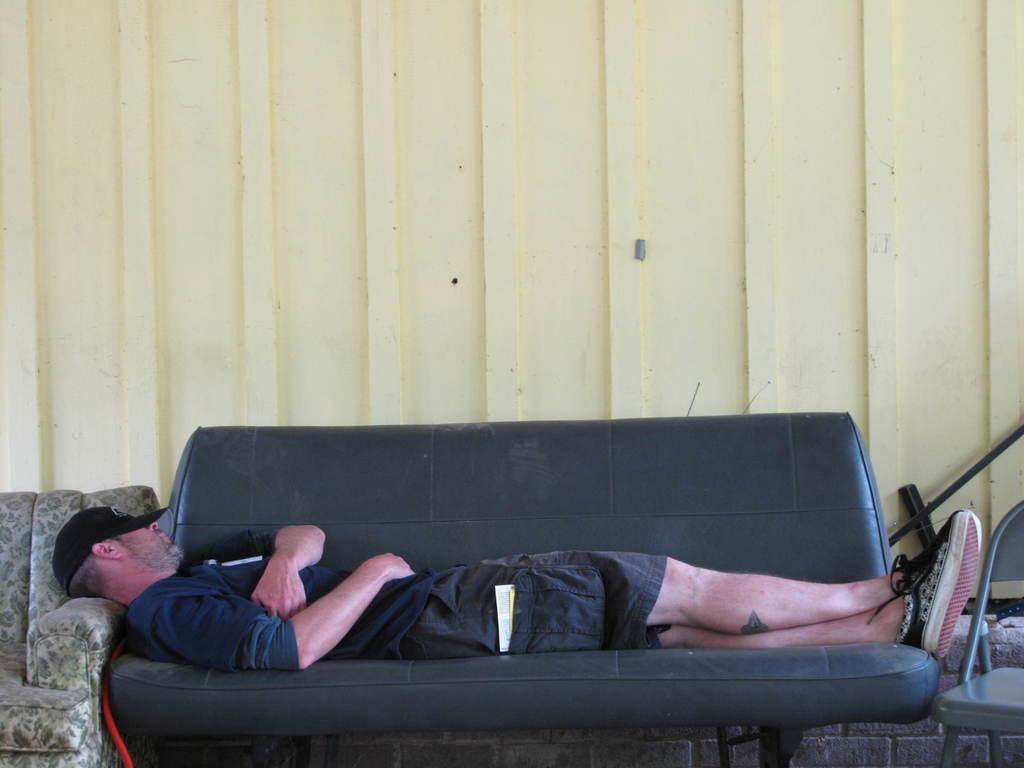Could you give a brief overview of what you see in this image? In the image there is a couch, on couch a man is lying. On right side we can see a chair in background there is a white color wall. 